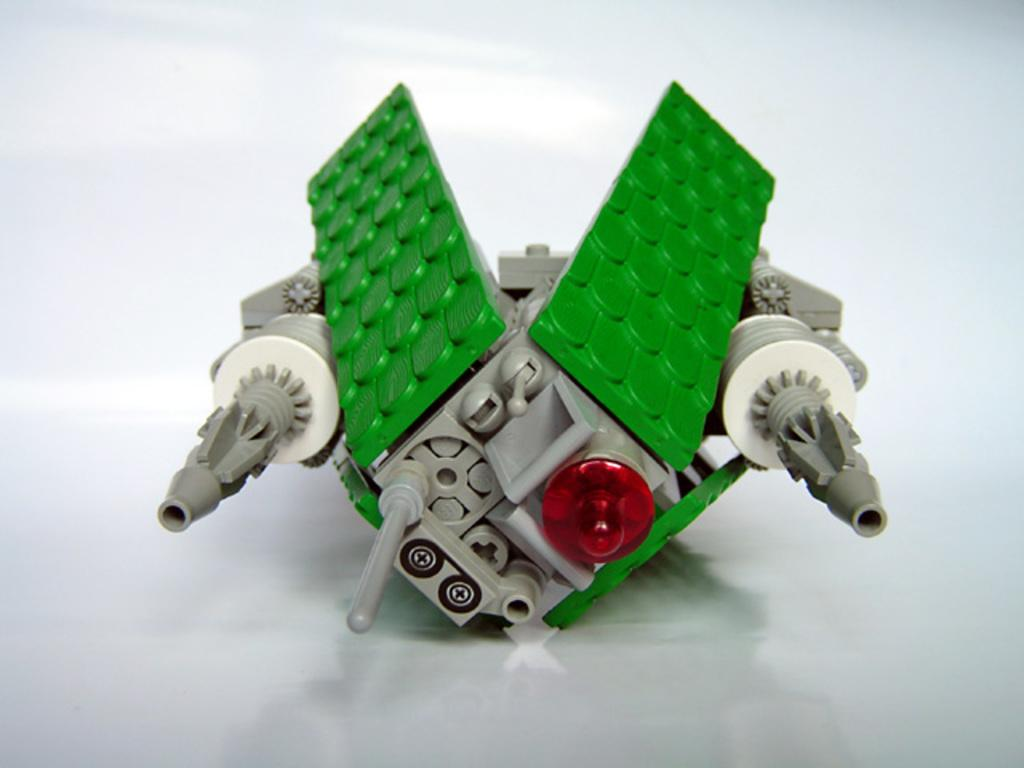What object can be seen in the image? There is a toy in the image. What color is the background of the image? The background of the image is white. What type of baseball equipment can be seen in the image? There is no baseball equipment present in the image; it features a toy and a white background. What role does zinc play in the image? Zinc is not mentioned or depicted in the image, so it does not have a role in the image. 